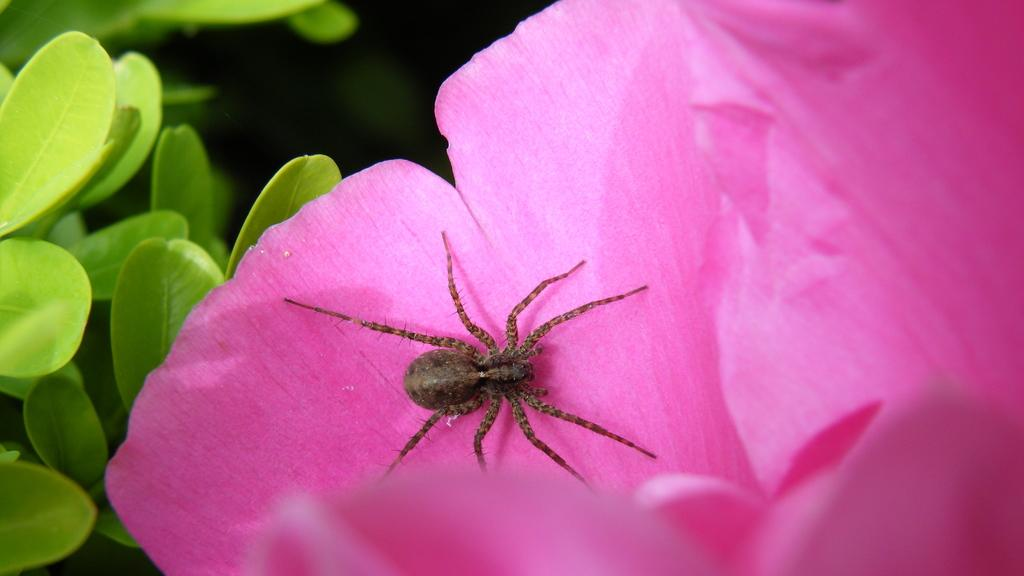What is on the flower in the image? There is a spider on the flower in the image. What color is the flower? The flower is pink in color. What can be seen on the left side of the image? There are leaves visible on the left side of the image. What type of copper material is used to make the coach in the image? There is no coach or copper material present in the image. 